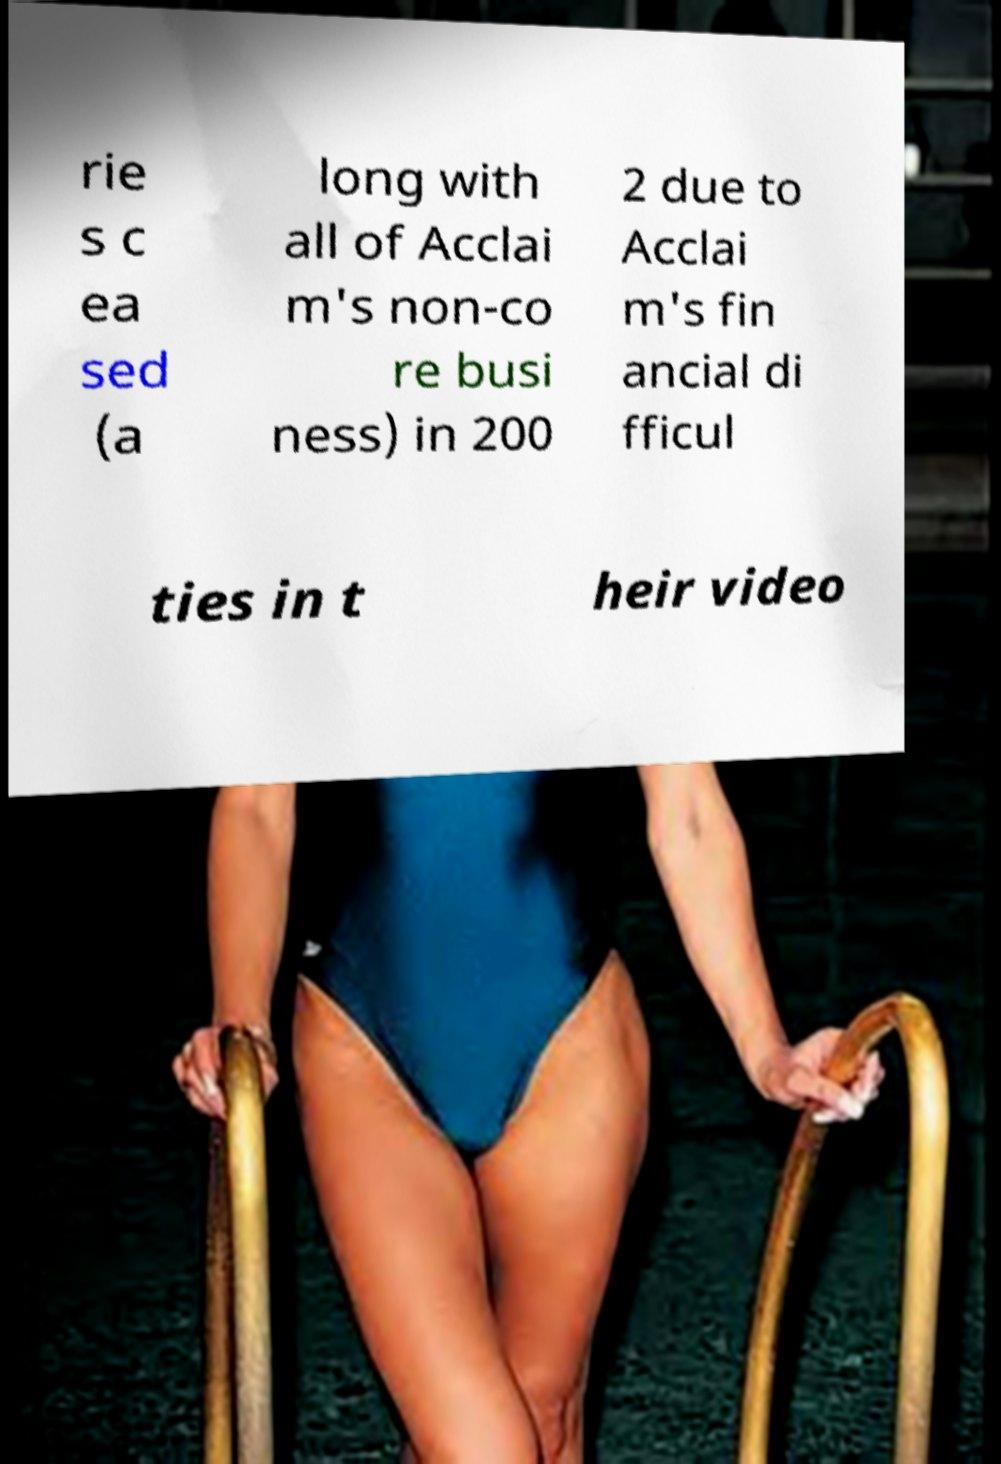What messages or text are displayed in this image? I need them in a readable, typed format. rie s c ea sed (a long with all of Acclai m's non-co re busi ness) in 200 2 due to Acclai m's fin ancial di fficul ties in t heir video 